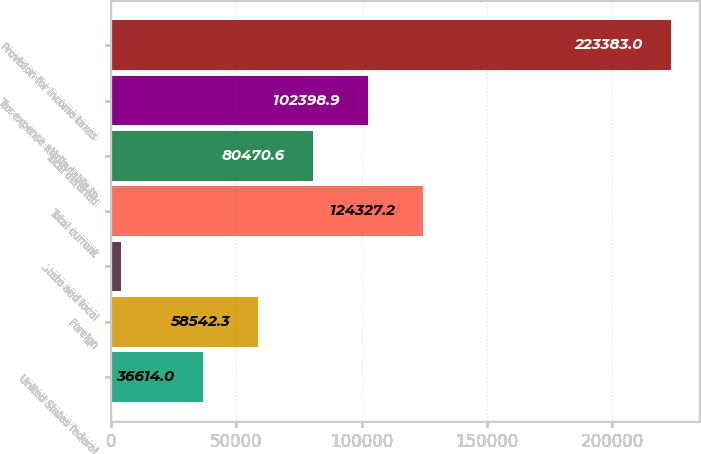Convert chart. <chart><loc_0><loc_0><loc_500><loc_500><bar_chart><fcel>United States federal<fcel>Foreign<fcel>State and local<fcel>Total current<fcel>Total deferred<fcel>Tax expense attributable to<fcel>Provision for income taxes<nl><fcel>36614<fcel>58542.3<fcel>4100<fcel>124327<fcel>80470.6<fcel>102399<fcel>223383<nl></chart> 